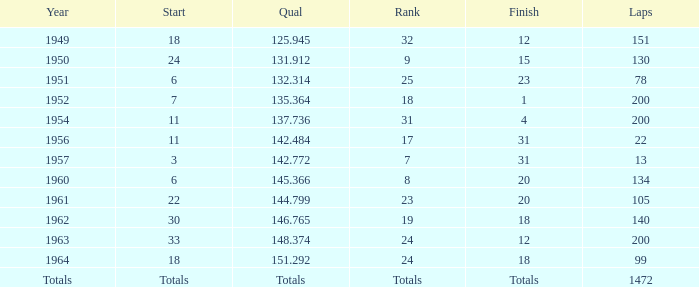374 qualification. 24.0. 